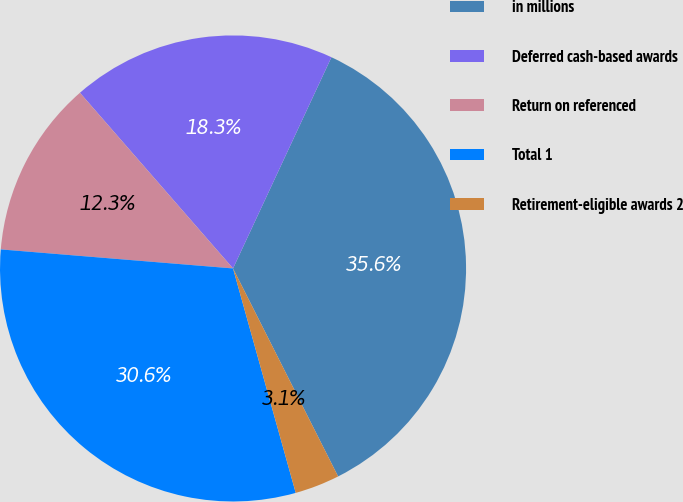Convert chart to OTSL. <chart><loc_0><loc_0><loc_500><loc_500><pie_chart><fcel>in millions<fcel>Deferred cash-based awards<fcel>Return on referenced<fcel>Total 1<fcel>Retirement-eligible awards 2<nl><fcel>35.62%<fcel>18.35%<fcel>12.29%<fcel>30.64%<fcel>3.11%<nl></chart> 